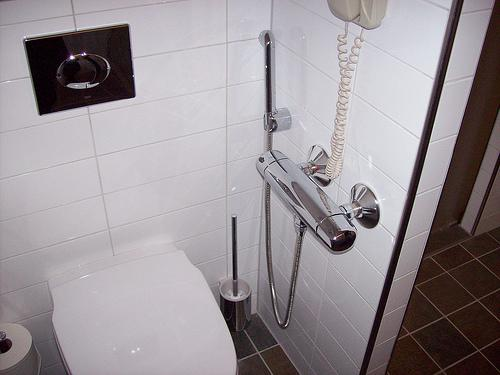Question: what type of flooring is shown?
Choices:
A. Wood.
B. Carpet.
C. Tile.
D. Vinyl.
Answer with the letter. Answer: C Question: how many people are in the photo?
Choices:
A. 2.
B. 3.
C. 0.
D. 4.
Answer with the letter. Answer: C Question: what color is the shower handle?
Choices:
A. Green.
B. Red.
C. Chrome.
D. Blue.
Answer with the letter. Answer: C Question: how many toilets are shown?
Choices:
A. 2.
B. 1.
C. 4.
D. 3.
Answer with the letter. Answer: B 